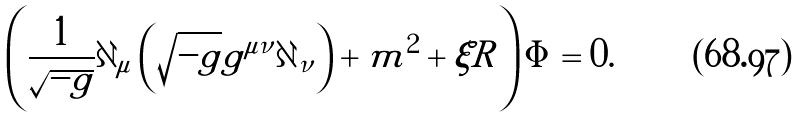<formula> <loc_0><loc_0><loc_500><loc_500>\left ( \frac { 1 } { \sqrt { - g } } \partial _ { \mu } \left ( \sqrt { - g } g ^ { \mu \nu } \partial _ { \nu } \right ) + m ^ { 2 } + \xi R \right ) \Phi = 0 .</formula> 